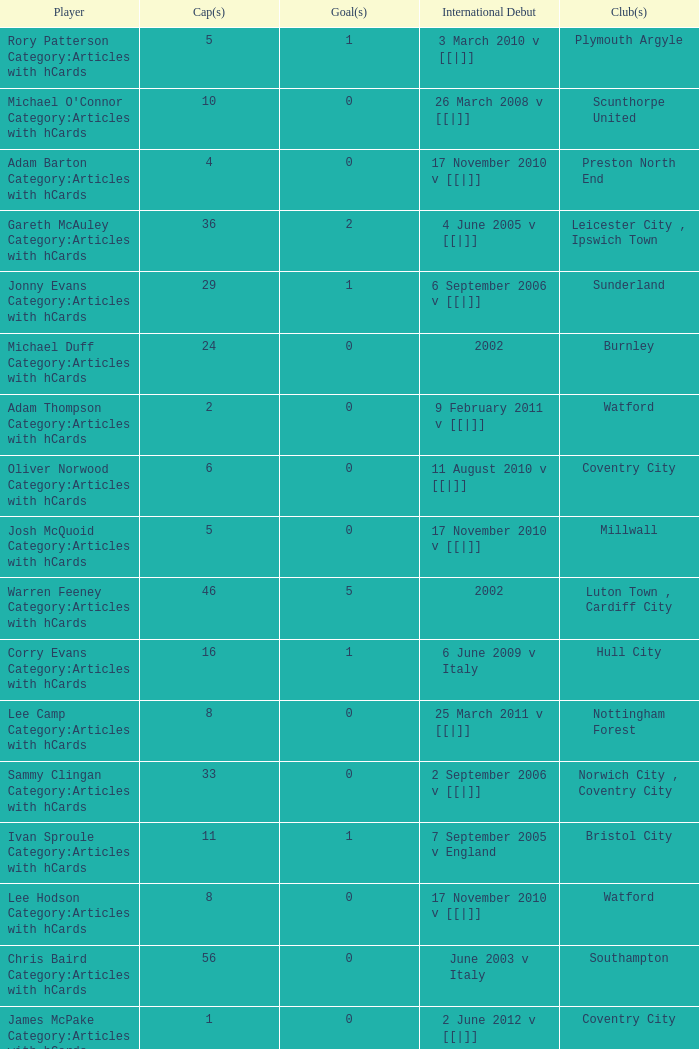How many caps figures for the Doncaster Rovers? 1.0. Could you parse the entire table as a dict? {'header': ['Player', 'Cap(s)', 'Goal(s)', 'International Debut', 'Club(s)'], 'rows': [['Rory Patterson Category:Articles with hCards', '5', '1', '3 March 2010 v [[|]]', 'Plymouth Argyle'], ["Michael O'Connor Category:Articles with hCards", '10', '0', '26 March 2008 v [[|]]', 'Scunthorpe United'], ['Adam Barton Category:Articles with hCards', '4', '0', '17 November 2010 v [[|]]', 'Preston North End'], ['Gareth McAuley Category:Articles with hCards', '36', '2', '4 June 2005 v [[|]]', 'Leicester City , Ipswich Town'], ['Jonny Evans Category:Articles with hCards', '29', '1', '6 September 2006 v [[|]]', 'Sunderland'], ['Michael Duff Category:Articles with hCards', '24', '0', '2002', 'Burnley'], ['Adam Thompson Category:Articles with hCards', '2', '0', '9 February 2011 v [[|]]', 'Watford'], ['Oliver Norwood Category:Articles with hCards', '6', '0', '11 August 2010 v [[|]]', 'Coventry City'], ['Josh McQuoid Category:Articles with hCards', '5', '0', '17 November 2010 v [[|]]', 'Millwall'], ['Warren Feeney Category:Articles with hCards', '46', '5', '2002', 'Luton Town , Cardiff City'], ['Corry Evans Category:Articles with hCards', '16', '1', '6 June 2009 v Italy', 'Hull City'], ['Lee Camp Category:Articles with hCards', '8', '0', '25 March 2011 v [[|]]', 'Nottingham Forest'], ['Sammy Clingan Category:Articles with hCards', '33', '0', '2 September 2006 v [[|]]', 'Norwich City , Coventry City'], ['Ivan Sproule Category:Articles with hCards', '11', '1', '7 September 2005 v England', 'Bristol City'], ['Lee Hodson Category:Articles with hCards', '8', '0', '17 November 2010 v [[|]]', 'Watford'], ['Chris Baird Category:Articles with hCards', '56', '0', 'June 2003 v Italy', 'Southampton'], ['James McPake Category:Articles with hCards', '1', '0', '2 June 2012 v [[|]]', 'Coventry City'], ['Grant McCann Category:Articles with hCards', '39', '4', '24 March 2007 v [[|]]', 'Barnsley , Scunthorpe United , Peterborough United'], ['Dean Shiels Category:Articles with hCards', '9', '0', '15 November 2005 v [[|]]', 'Doncaster Rovers'], ['Chris Brunt Category:Articles with hCards', '36', '1', '2004', 'Sheffield Wednesday , West Bromwich Albion'], ['Craig Cathcart Category:Articles with hCards', '9', '0', '3 September 2010 v [[|]]', 'Blackpool'], ['David Healy Category:Articles with hCards', '93', '35', '23 February 2000 v [[|]]', 'Leeds United , Ipswich Town'], ['Maik Taylor Category:Articles with hCards', '88', '0', '27 March 1999 v [[|]]', 'Birmingham City'], ['George McCartney Category:Articles with hCards', '34', '1', 'September 2001 v [[|]]', 'Sunderland'], ['Kyle Lafferty Category:Articles with hCards', '31', '8', '2006 v [[|]]', 'Barnsley'], ['Michael Bryan Category:Articles with hCards', '2', '0', '26 May 2010 v Turkey', 'Watford'], ['Damien Johnson Category:Articles with hCards', '56', '0', '29 May 1999 v Republic of Ireland', 'Birmingham City , Plymouth Argyle'], ['Ryan McGivern Category:Articles with hCards', '16', '0', '21 August 2008 v [[|]]', 'Leicester City , Bristol City'], ['Josh Carson Category:Articles with hCards', '3', '0', '9 September 2010 v [[|]]', 'Ipswich Town'], ['Martin Paterson Category:Articles with hCards', '13', '0', '2007', 'Scunthorpe United , Burnley'], ['Josh Magennis Category:Articles with hCards', '3', '0', '26 May 2010 v Turkey', 'Cardiff City']]} 